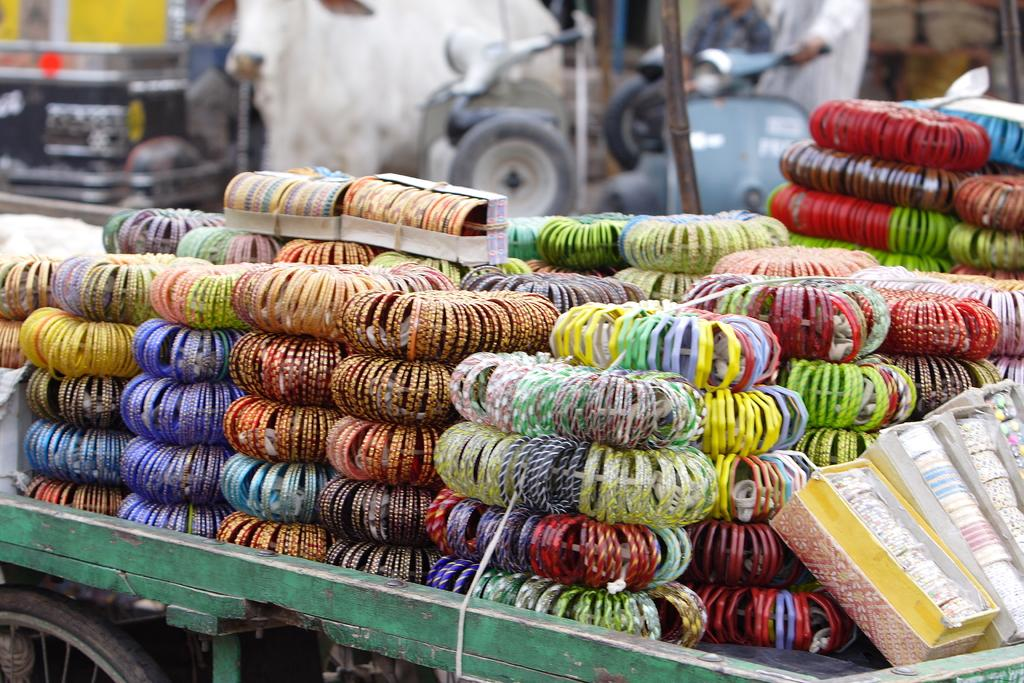What is adorned with many bangles in the image? There are many bangles on a vehicle in the image. What else can be seen in the background of the image? There are vehicles and people in the background of the image. What is located on the right side of the image? There are some bags on the right side of the image. How many mice are sitting on the bangles in the image? There are no mice present in the image; it only features a vehicle with bangles and other elements mentioned in the conversation. 